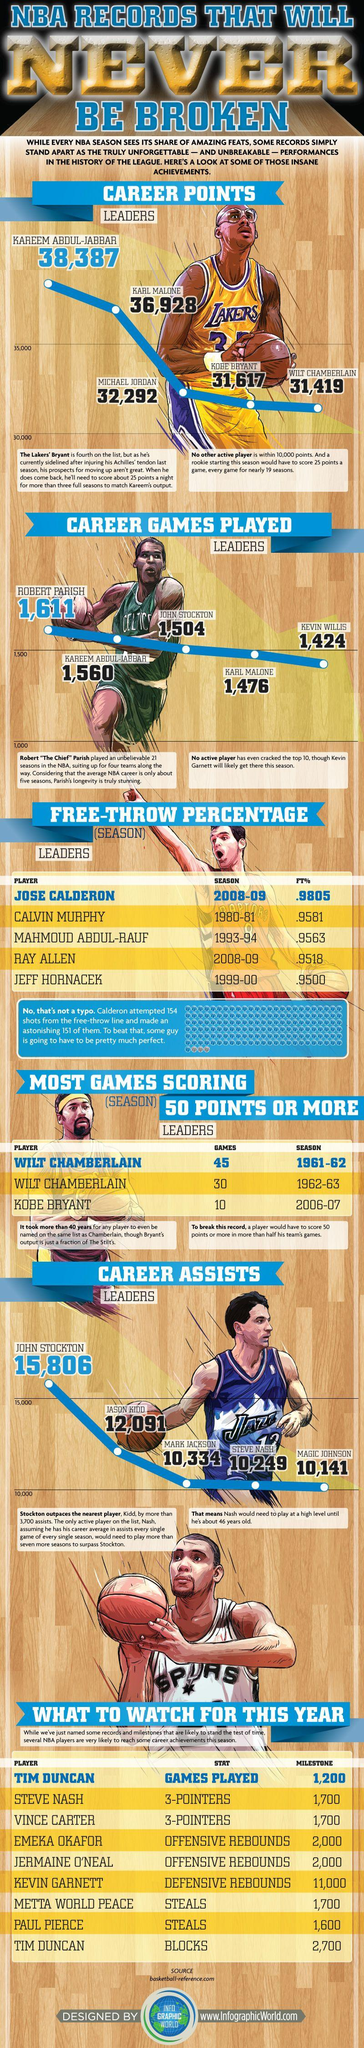Specify some key components in this picture. Magic Johnson accumulated 10,141 assists during his playing career, making him one of the most prolific passers in NBA history. The highest number of three-pointers scored this year was 1,700. Tim Duncan, the player who scored the highest number of blocks and played the most number of games, is the answer to the question. Kareem Abdul-Jabbar, a basketball player with the highest career points and the second highest number of games played, is a dominant force in the sport. The third column and third row of the table contain the percentage value of 0.9563. 